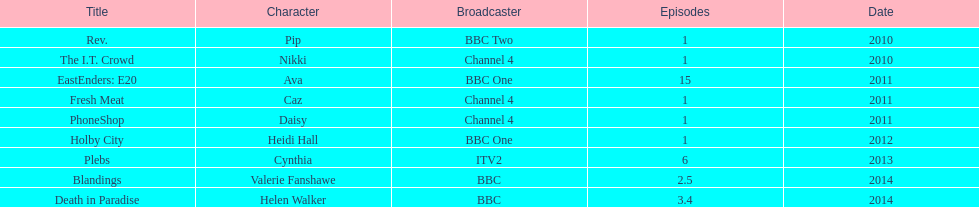How many titles consist of a minimum of 5 episodes? 2. 